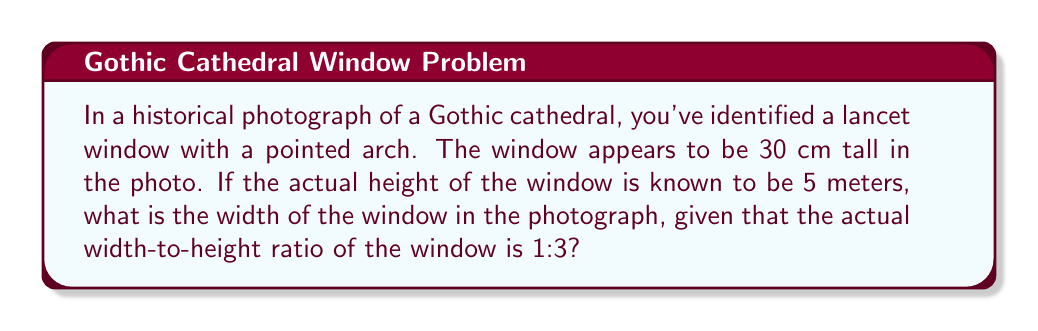Help me with this question. Let's approach this step-by-step:

1) First, we need to establish the scale factor between the photograph and reality. We can do this using the height:

   Scale factor = $\frac{\text{Photo height}}{\text{Actual height}} = \frac{30 \text{ cm}}{5 \text{ m}} = \frac{30 \text{ cm}}{500 \text{ cm}} = \frac{3}{50} = 0.06$

2) Now, we know that the actual width-to-height ratio is 1:3. This means:

   $\frac{\text{Actual width}}{\text{Actual height}} = \frac{1}{3}$

3) We can find the actual width:

   $\text{Actual width} = \frac{1}{3} \times \text{Actual height} = \frac{1}{3} \times 5 \text{ m} = \frac{5}{3} \text{ m} = 1.67 \text{ m}$

4) To find the width in the photograph, we multiply the actual width by the scale factor:

   $\text{Photo width} = \text{Actual width} \times \text{Scale factor}$
   
   $\text{Photo width} = 167 \text{ cm} \times 0.06 = 10 \text{ cm}$

Therefore, the width of the window in the photograph is 10 cm.
Answer: 10 cm 